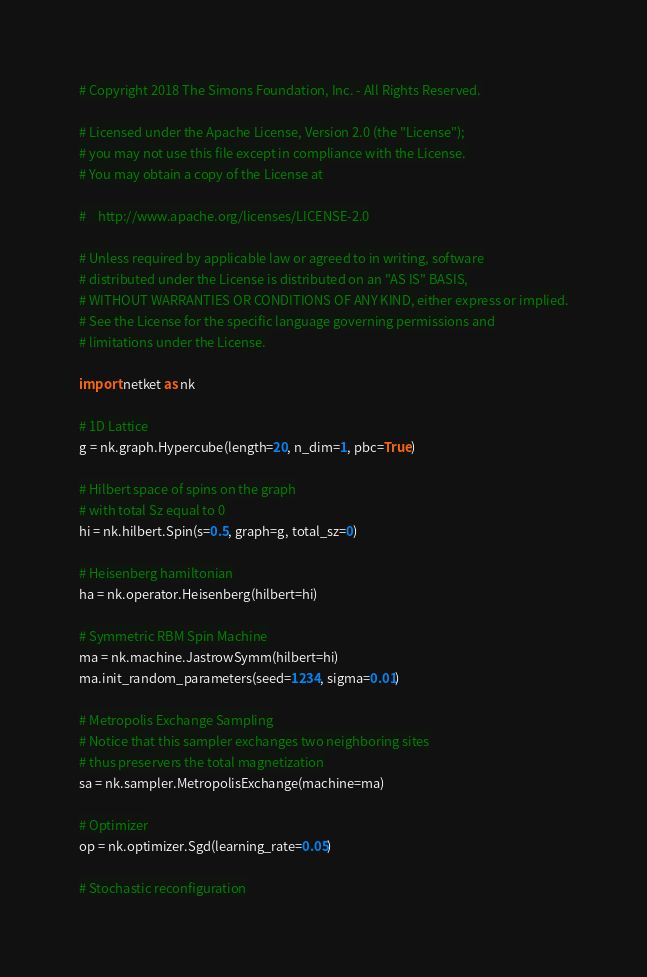<code> <loc_0><loc_0><loc_500><loc_500><_Python_># Copyright 2018 The Simons Foundation, Inc. - All Rights Reserved.

# Licensed under the Apache License, Version 2.0 (the "License");
# you may not use this file except in compliance with the License.
# You may obtain a copy of the License at

#    http://www.apache.org/licenses/LICENSE-2.0

# Unless required by applicable law or agreed to in writing, software
# distributed under the License is distributed on an "AS IS" BASIS,
# WITHOUT WARRANTIES OR CONDITIONS OF ANY KIND, either express or implied.
# See the License for the specific language governing permissions and
# limitations under the License.

import netket as nk

# 1D Lattice
g = nk.graph.Hypercube(length=20, n_dim=1, pbc=True)

# Hilbert space of spins on the graph
# with total Sz equal to 0
hi = nk.hilbert.Spin(s=0.5, graph=g, total_sz=0)

# Heisenberg hamiltonian
ha = nk.operator.Heisenberg(hilbert=hi)

# Symmetric RBM Spin Machine
ma = nk.machine.JastrowSymm(hilbert=hi)
ma.init_random_parameters(seed=1234, sigma=0.01)

# Metropolis Exchange Sampling
# Notice that this sampler exchanges two neighboring sites
# thus preservers the total magnetization
sa = nk.sampler.MetropolisExchange(machine=ma)

# Optimizer
op = nk.optimizer.Sgd(learning_rate=0.05)

# Stochastic reconfiguration</code> 